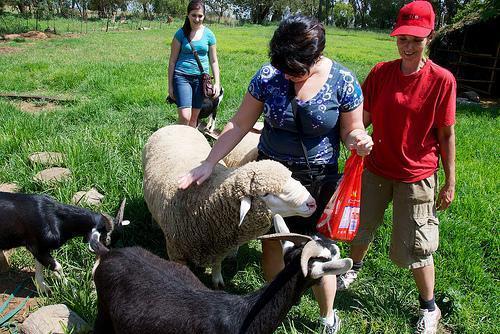How many people are in the picture?
Give a very brief answer. 3. How many sheep are there?
Give a very brief answer. 1. How many people are wearing hats?
Give a very brief answer. 1. 